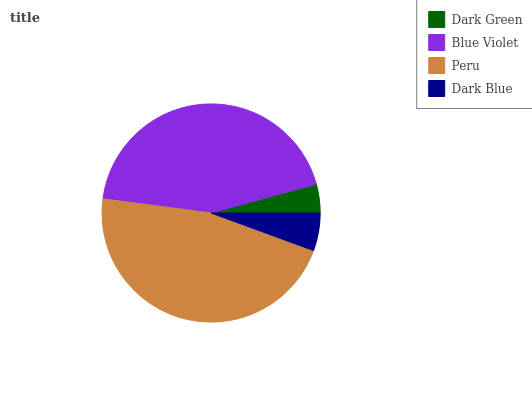Is Dark Green the minimum?
Answer yes or no. Yes. Is Peru the maximum?
Answer yes or no. Yes. Is Blue Violet the minimum?
Answer yes or no. No. Is Blue Violet the maximum?
Answer yes or no. No. Is Blue Violet greater than Dark Green?
Answer yes or no. Yes. Is Dark Green less than Blue Violet?
Answer yes or no. Yes. Is Dark Green greater than Blue Violet?
Answer yes or no. No. Is Blue Violet less than Dark Green?
Answer yes or no. No. Is Blue Violet the high median?
Answer yes or no. Yes. Is Dark Blue the low median?
Answer yes or no. Yes. Is Dark Blue the high median?
Answer yes or no. No. Is Blue Violet the low median?
Answer yes or no. No. 